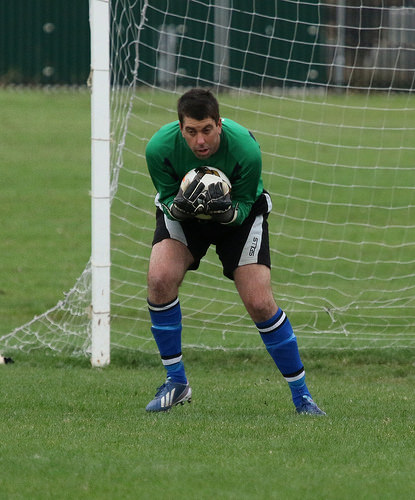<image>
Is the goal keeper behind the football? Yes. From this viewpoint, the goal keeper is positioned behind the football, with the football partially or fully occluding the goal keeper. 